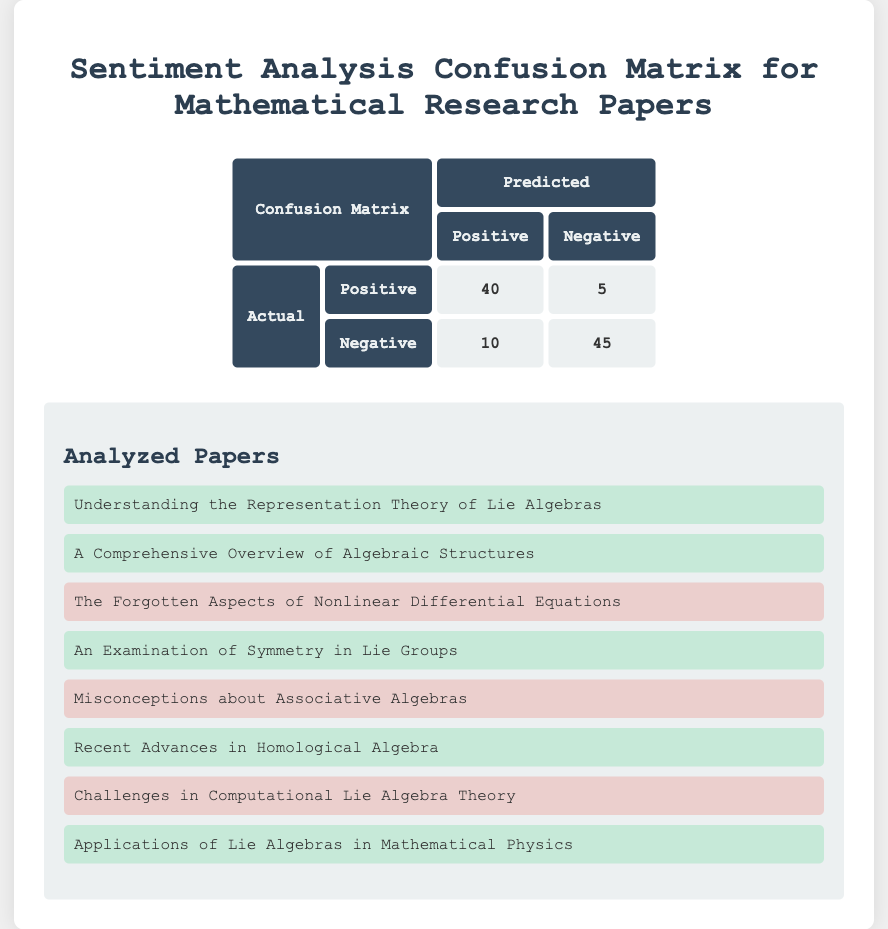What is the number of true positives? The true positives are directly labeled in the confusion matrix as 40.
Answer: 40 What is the number of false negatives? The number of false negatives is listed in the confusion matrix as 5.
Answer: 5 How many predictions were made in total? To find the total predictions, we add the true positives, false positives, false negatives, and true negatives: 40 + 10 + 5 + 45 = 100.
Answer: 100 What is the precision of the sentiment classification? Precision is calculated as true positives divided by the sum of true positives and false positives: 40 / (40 + 10) = 40 / 50 = 0.8, or 80%.
Answer: 80% Is the number of true negatives greater than the number of false negatives? The confusion matrix shows 45 true negatives and 5 false negatives. Since 45 is greater than 5, the answer is yes.
Answer: Yes What is the total number of positive sentiments predicted? To find the total predicted positive sentiments, we sum the true positives and false positives: 40 + 10 = 50.
Answer: 50 What is the overall accuracy of the sentiment classification? Accuracy is calculated as the sum of true positives and true negatives divided by the total predictions: (40 + 45) / 100 = 85 / 100 = 0.85, or 85%.
Answer: 85% If we consider only the negative sentiment papers, what is the number of correct predictions? The number of correct predictions for negative sentiment papers is given by true negatives, which is 45.
Answer: 45 What is the number of papers classified incorrectly as positive? The number classified incorrectly as positive corresponds to false positives, which is 10.
Answer: 10 